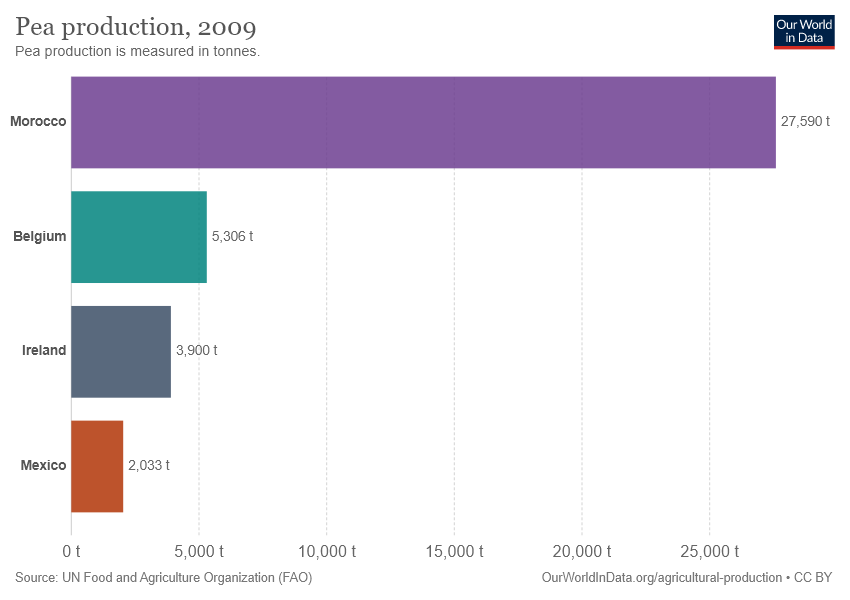Point out several critical features in this image. The sum of the smallest two bars is greater than the second largest bar. The name of the largest bar is Morocco. 